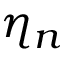Convert formula to latex. <formula><loc_0><loc_0><loc_500><loc_500>\eta _ { n }</formula> 